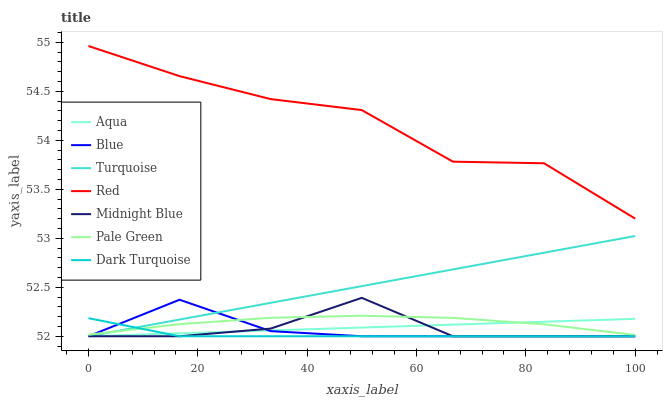Does Dark Turquoise have the minimum area under the curve?
Answer yes or no. Yes. Does Red have the maximum area under the curve?
Answer yes or no. Yes. Does Turquoise have the minimum area under the curve?
Answer yes or no. No. Does Turquoise have the maximum area under the curve?
Answer yes or no. No. Is Aqua the smoothest?
Answer yes or no. Yes. Is Red the roughest?
Answer yes or no. Yes. Is Turquoise the smoothest?
Answer yes or no. No. Is Turquoise the roughest?
Answer yes or no. No. Does Blue have the lowest value?
Answer yes or no. Yes. Does Pale Green have the lowest value?
Answer yes or no. No. Does Red have the highest value?
Answer yes or no. Yes. Does Turquoise have the highest value?
Answer yes or no. No. Is Dark Turquoise less than Red?
Answer yes or no. Yes. Is Red greater than Aqua?
Answer yes or no. Yes. Does Midnight Blue intersect Dark Turquoise?
Answer yes or no. Yes. Is Midnight Blue less than Dark Turquoise?
Answer yes or no. No. Is Midnight Blue greater than Dark Turquoise?
Answer yes or no. No. Does Dark Turquoise intersect Red?
Answer yes or no. No. 